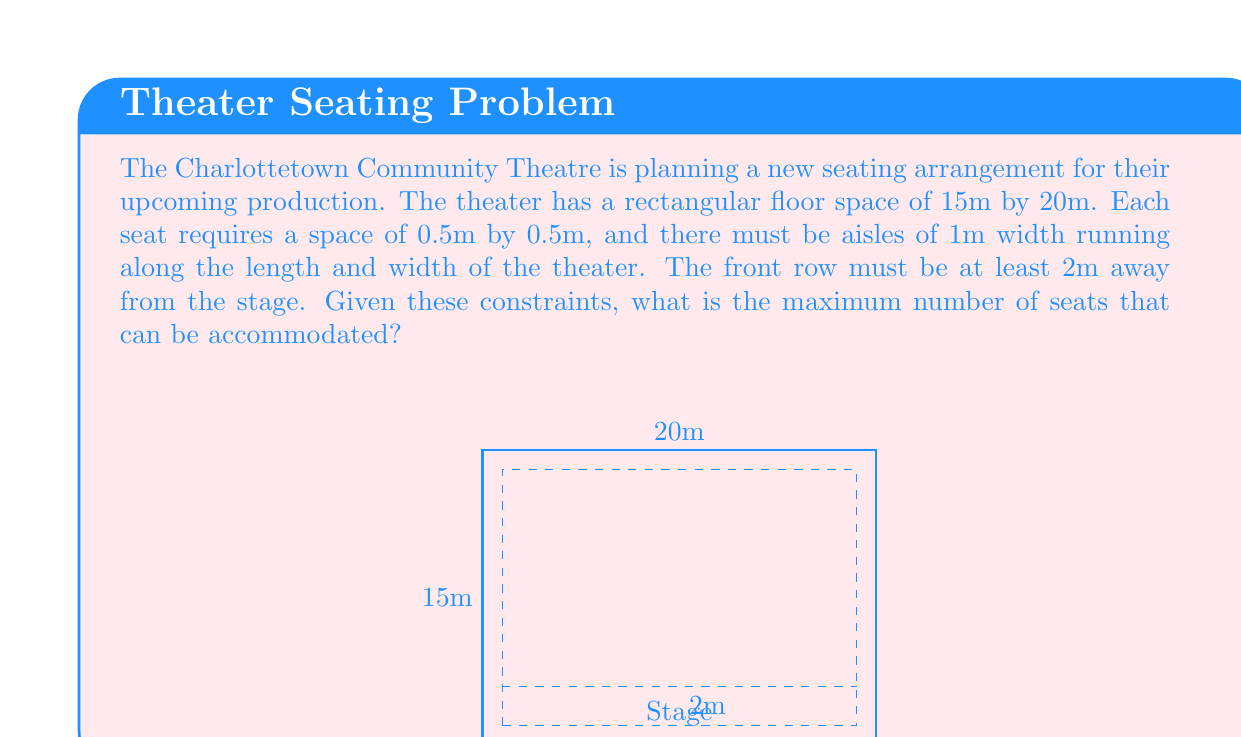Could you help me with this problem? Let's approach this step-by-step:

1) First, we need to calculate the available space for seating:
   - Width: 20m - 2m (aisles) = 18m
   - Length: 15m - 2m (front space) - 1m (back aisle) = 12m

2) Now, let's calculate how many seats can fit in each row and column:
   - Seats per row: $\lfloor 18 \div 0.5 \rfloor = 36$ seats
   - Number of rows: $\lfloor 12 \div 0.5 \rfloor = 24$ rows

3) However, we need to account for the aisle along the length:
   - Let's place the aisle after every 6 rows
   - This means we lose 4 rows for aisles (24 ÷ 6 = 4)
   - Actual number of rows: 24 - 4 = 20 rows

4) Calculate the total number of seats:
   $$ \text{Total seats} = 36 \times 20 = 720 $$

Therefore, the maximum number of seats that can be accommodated is 720.
Answer: 720 seats 